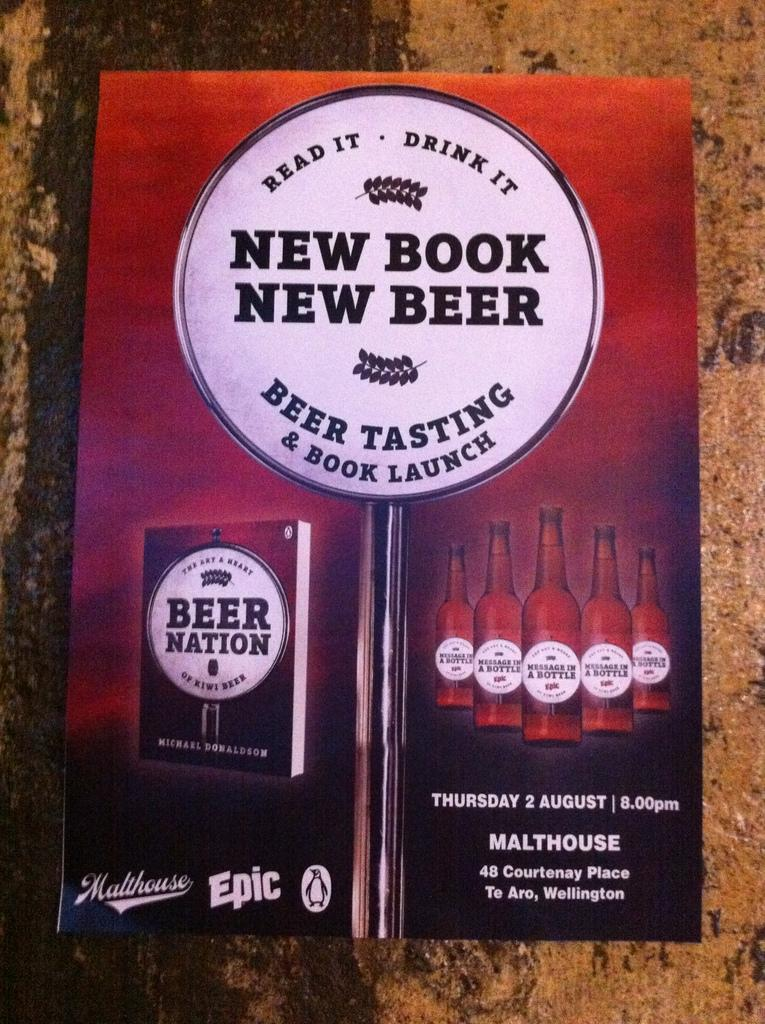<image>
Give a short and clear explanation of the subsequent image. A gradient orange, brown and black poster with the writing New Book New Beer Beer tasting and Book Launch in the center and beer bottles and a book design 